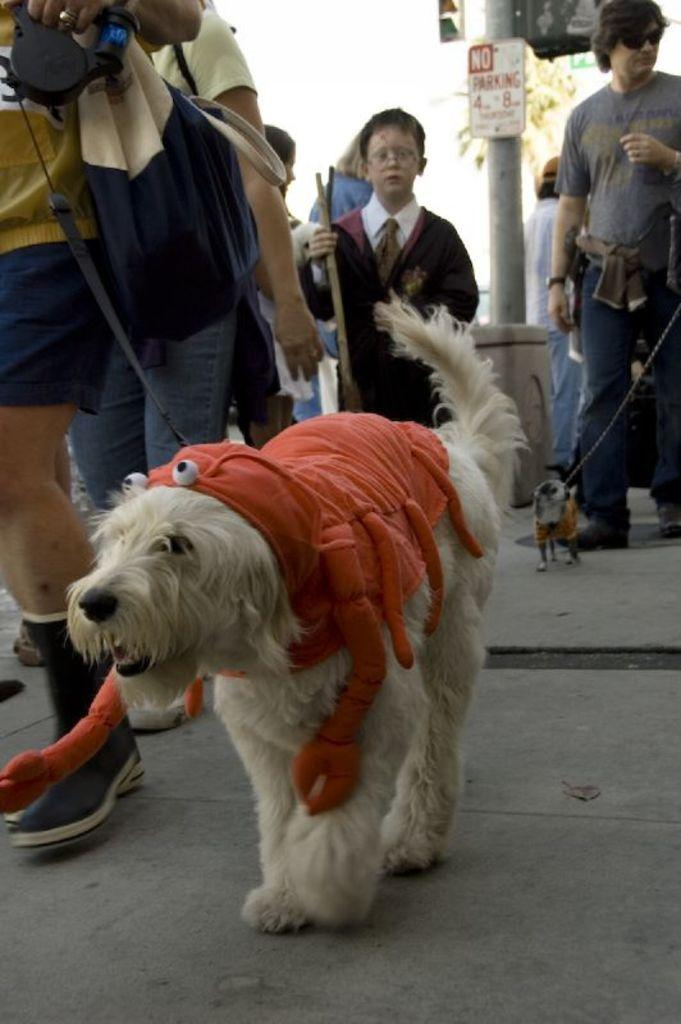How many people are in the image? There is a group of people in the image, but the exact number cannot be determined from the provided facts. What other living creatures are present in the image? There are dogs in the image. What type of vegetation can be seen in the image? There is a tree visible in the image. What is visible in the background of the image? The sky is visible in the image. What type of mint is growing on the tree in the image? There is no mention of mint in the image, and the tree is not described in detail. 